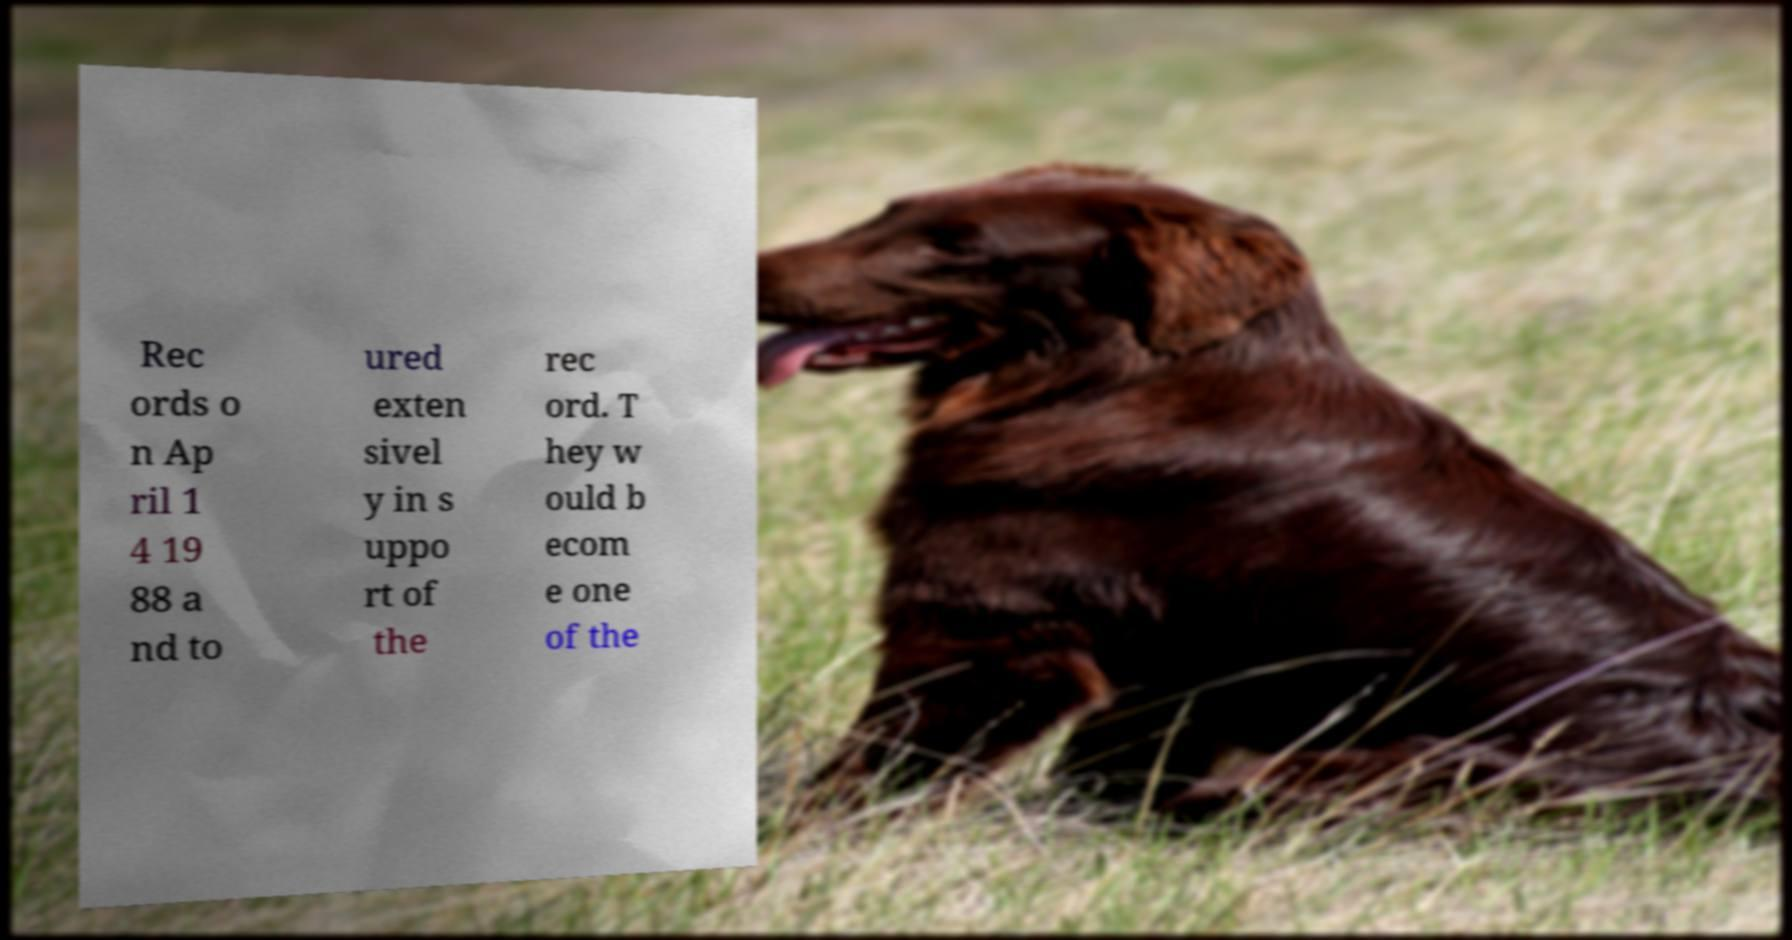Can you accurately transcribe the text from the provided image for me? Rec ords o n Ap ril 1 4 19 88 a nd to ured exten sivel y in s uppo rt of the rec ord. T hey w ould b ecom e one of the 